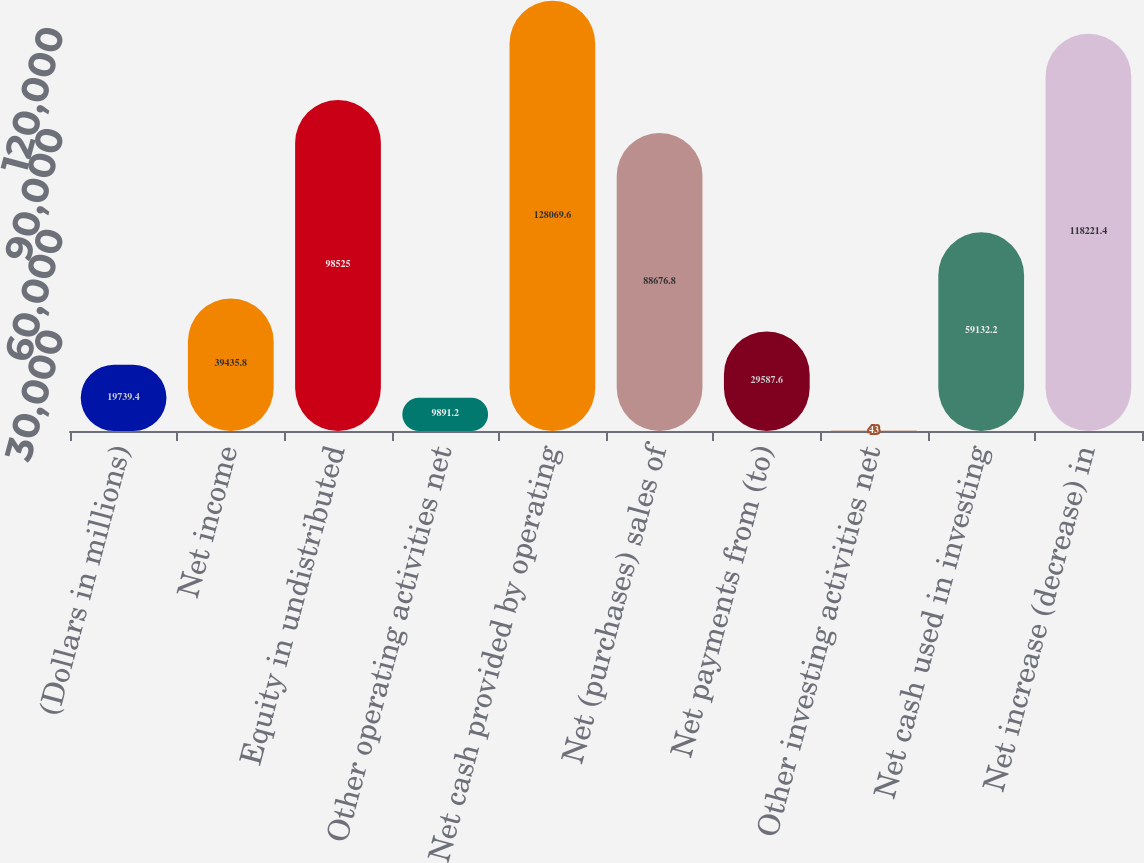Convert chart. <chart><loc_0><loc_0><loc_500><loc_500><bar_chart><fcel>(Dollars in millions)<fcel>Net income<fcel>Equity in undistributed<fcel>Other operating activities net<fcel>Net cash provided by operating<fcel>Net (purchases) sales of<fcel>Net payments from (to)<fcel>Other investing activities net<fcel>Net cash used in investing<fcel>Net increase (decrease) in<nl><fcel>19739.4<fcel>39435.8<fcel>98525<fcel>9891.2<fcel>128070<fcel>88676.8<fcel>29587.6<fcel>43<fcel>59132.2<fcel>118221<nl></chart> 